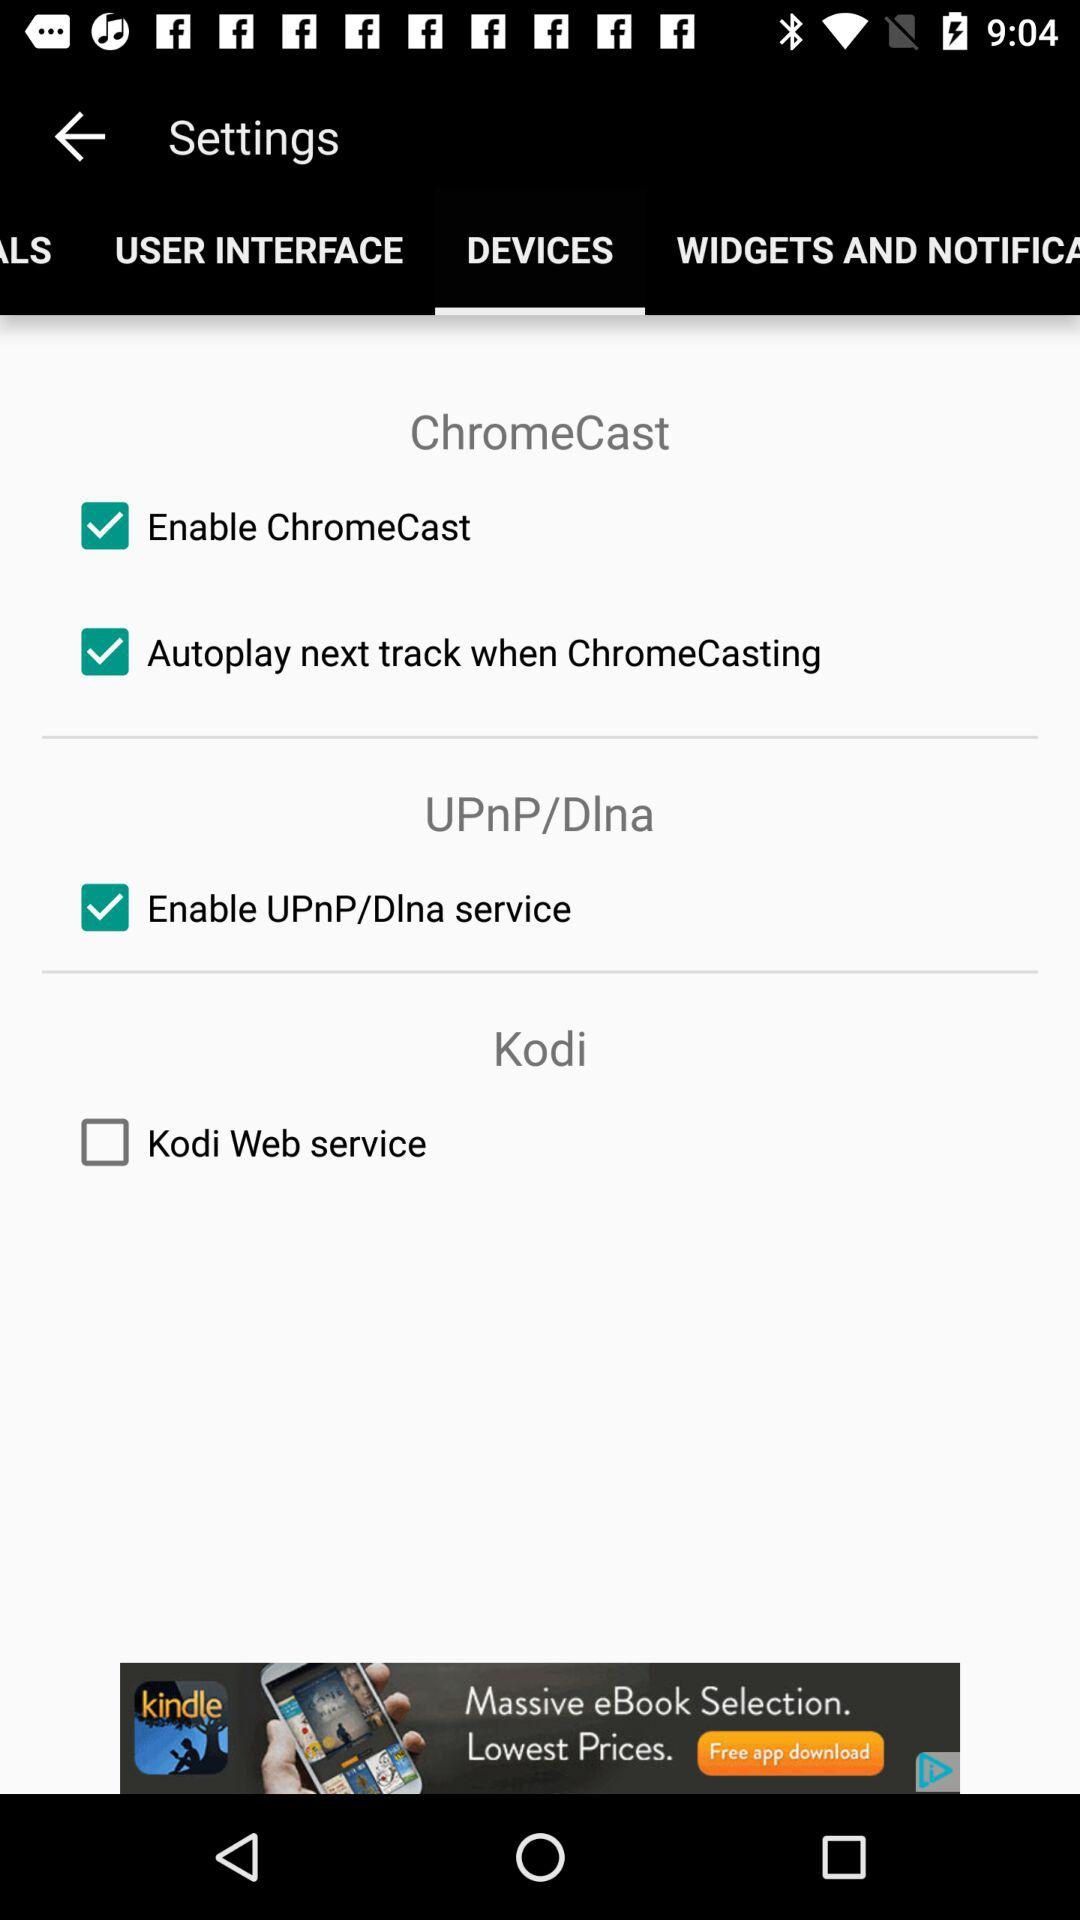What is the status of "Enable ChromeCast"? The status is "on". 